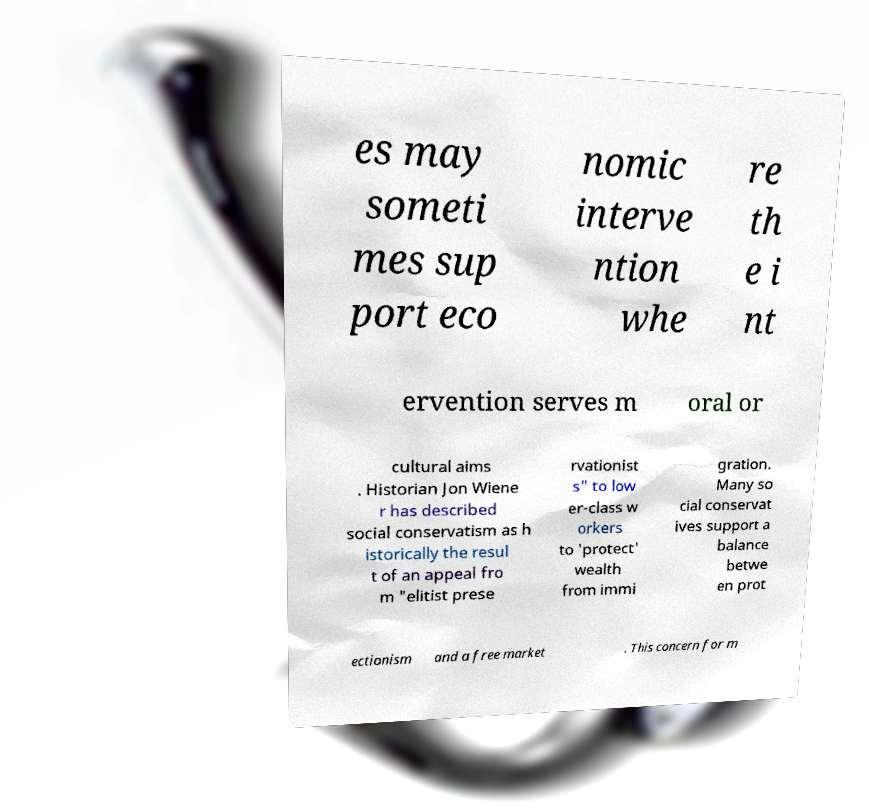There's text embedded in this image that I need extracted. Can you transcribe it verbatim? es may someti mes sup port eco nomic interve ntion whe re th e i nt ervention serves m oral or cultural aims . Historian Jon Wiene r has described social conservatism as h istorically the resul t of an appeal fro m "elitist prese rvationist s" to low er-class w orkers to 'protect' wealth from immi gration. Many so cial conservat ives support a balance betwe en prot ectionism and a free market . This concern for m 